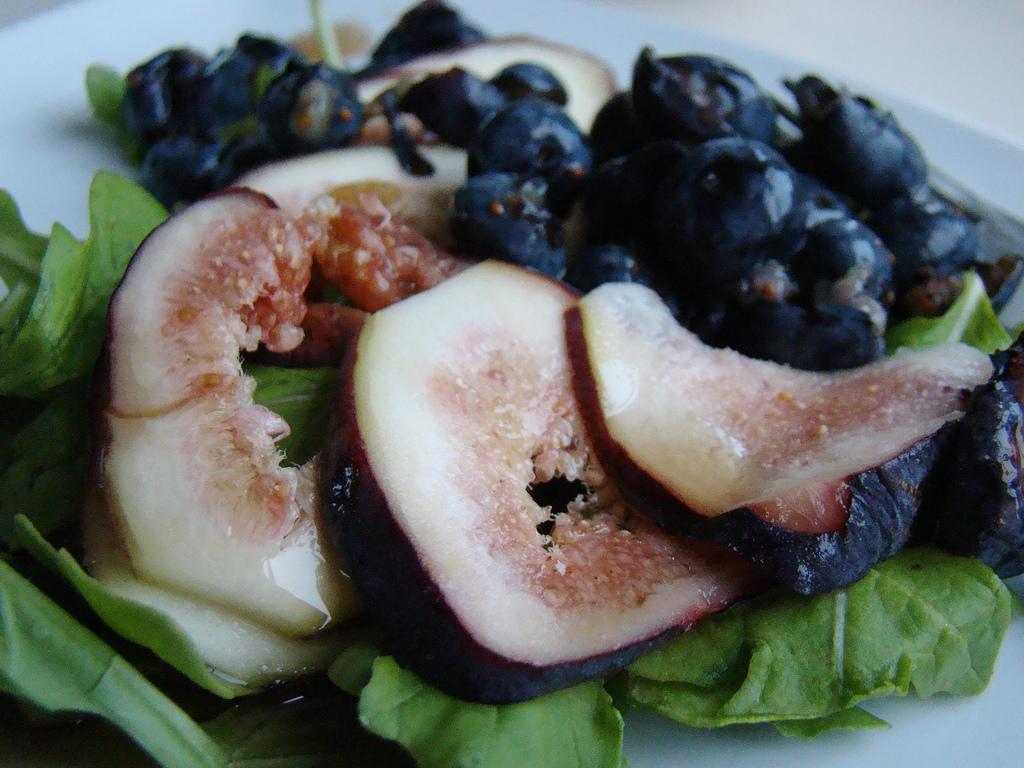Please provide a concise description of this image. In this picture there are few eatables placed in a plate. 